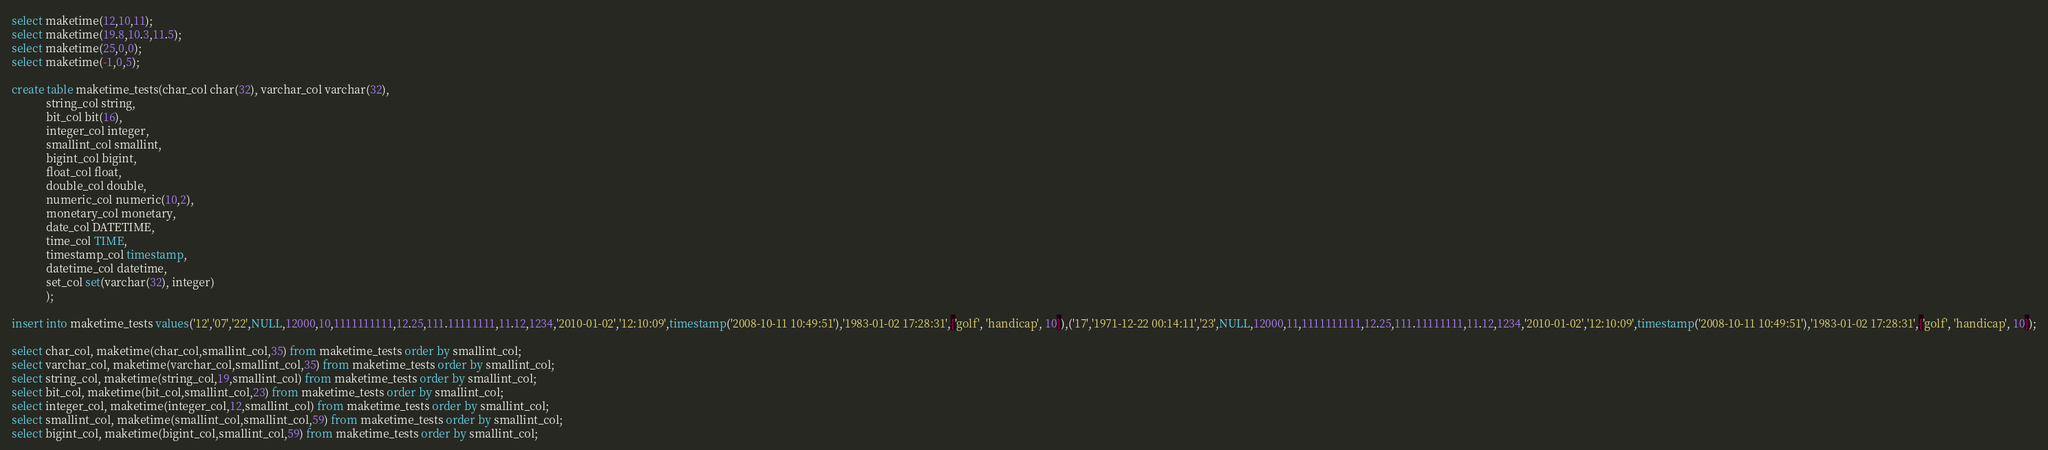<code> <loc_0><loc_0><loc_500><loc_500><_SQL_>select maketime(12,10,11);
select maketime(19.8,10.3,11.5);
select maketime(25,0,0);
select maketime(-1,0,5);

create table maketime_tests(char_col char(32), varchar_col varchar(32), 
			string_col string, 
			bit_col bit(16), 
			integer_col integer,
			smallint_col smallint,
			bigint_col bigint,
			float_col float,
			double_col double, 
			numeric_col numeric(10,2),
			monetary_col monetary,
			date_col DATETIME, 
			time_col TIME,
			timestamp_col timestamp,
			datetime_col datetime,
			set_col set(varchar(32), integer)
			);

insert into maketime_tests values('12','07','22',NULL,12000,10,1111111111,12.25,111.11111111,11.12,1234,'2010-01-02','12:10:09',timestamp('2008-10-11 10:49:51'),'1983-01-02 17:28:31',{'golf', 'handicap', 10}),('17','1971-12-22 00:14:11','23',NULL,12000,11,1111111111,12.25,111.11111111,11.12,1234,'2010-01-02','12:10:09',timestamp('2008-10-11 10:49:51'),'1983-01-02 17:28:31',{'golf', 'handicap', 10});

select char_col, maketime(char_col,smallint_col,35) from maketime_tests order by smallint_col;
select varchar_col, maketime(varchar_col,smallint_col,35) from maketime_tests order by smallint_col;
select string_col, maketime(string_col,19,smallint_col) from maketime_tests order by smallint_col;
select bit_col, maketime(bit_col,smallint_col,23) from maketime_tests order by smallint_col;
select integer_col, maketime(integer_col,12,smallint_col) from maketime_tests order by smallint_col;
select smallint_col, maketime(smallint_col,smallint_col,59) from maketime_tests order by smallint_col;
select bigint_col, maketime(bigint_col,smallint_col,59) from maketime_tests order by smallint_col;</code> 